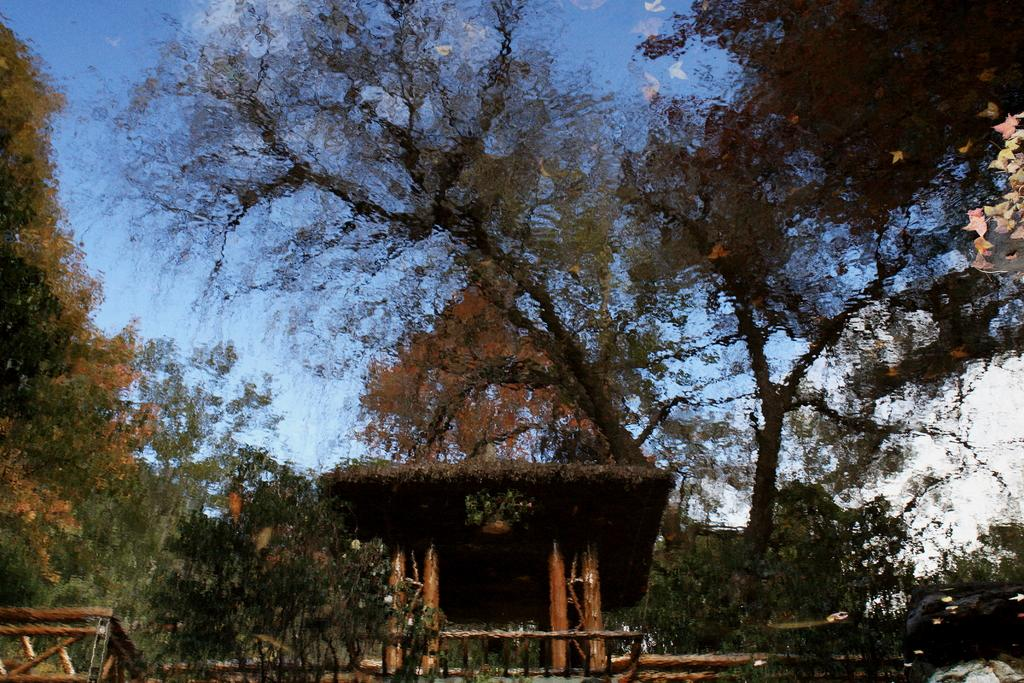What is the main subject of the portrait painting in the image? The main subject of the portrait painting in the image is a hut. What materials are used in the construction of the hut? The provided facts do not specify the materials used in the construction of the hut. However, we can see wooden poles in the image, which might be part of the hut's structure. What other natural elements are present in the image? There are trees and the sky in the image. What is the condition of the sky in the image? The sky is clear in the image. What type of mask is being worn by the hut in the image? There is no mask present in the image, as it features a portrait painting of a hut. How many balls are visible in the image? There are no balls present in the image. 